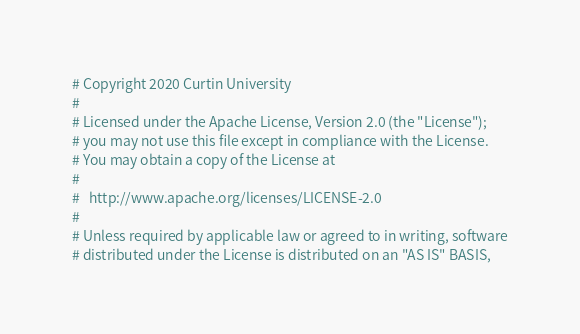<code> <loc_0><loc_0><loc_500><loc_500><_Python_># Copyright 2020 Curtin University
#
# Licensed under the Apache License, Version 2.0 (the "License");
# you may not use this file except in compliance with the License.
# You may obtain a copy of the License at
#
#   http://www.apache.org/licenses/LICENSE-2.0
#
# Unless required by applicable law or agreed to in writing, software
# distributed under the License is distributed on an "AS IS" BASIS,</code> 